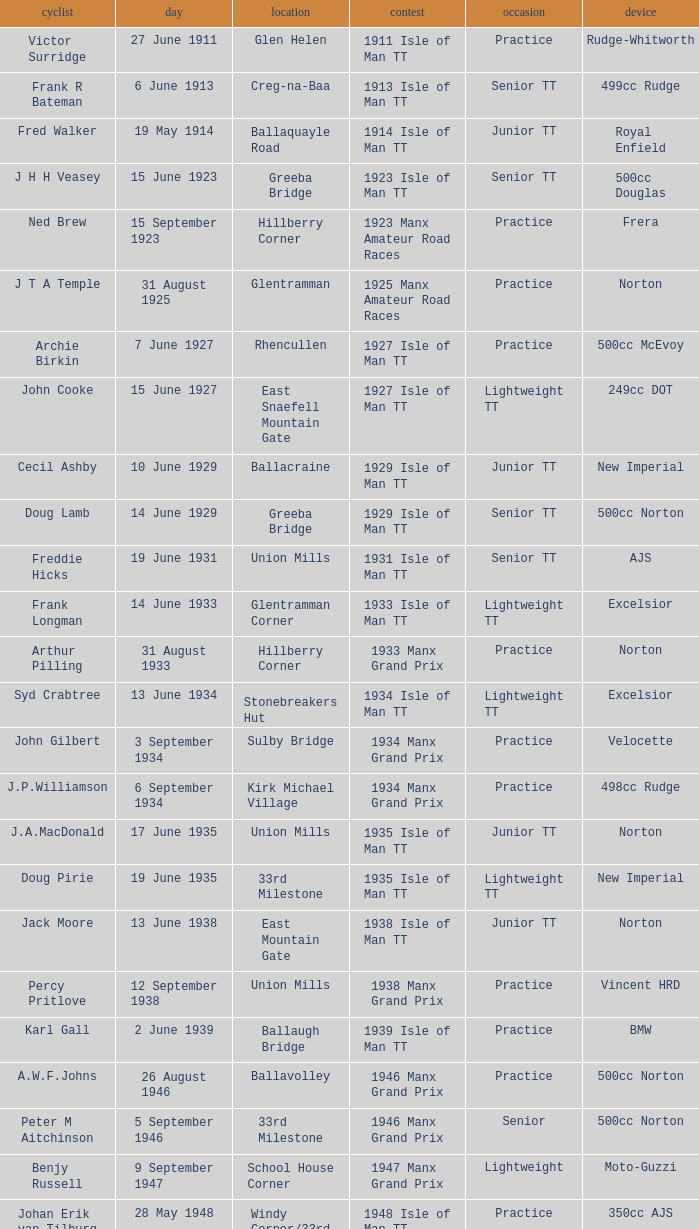Harry l Stephen rides a Norton machine on what date? 8 June 1953. 